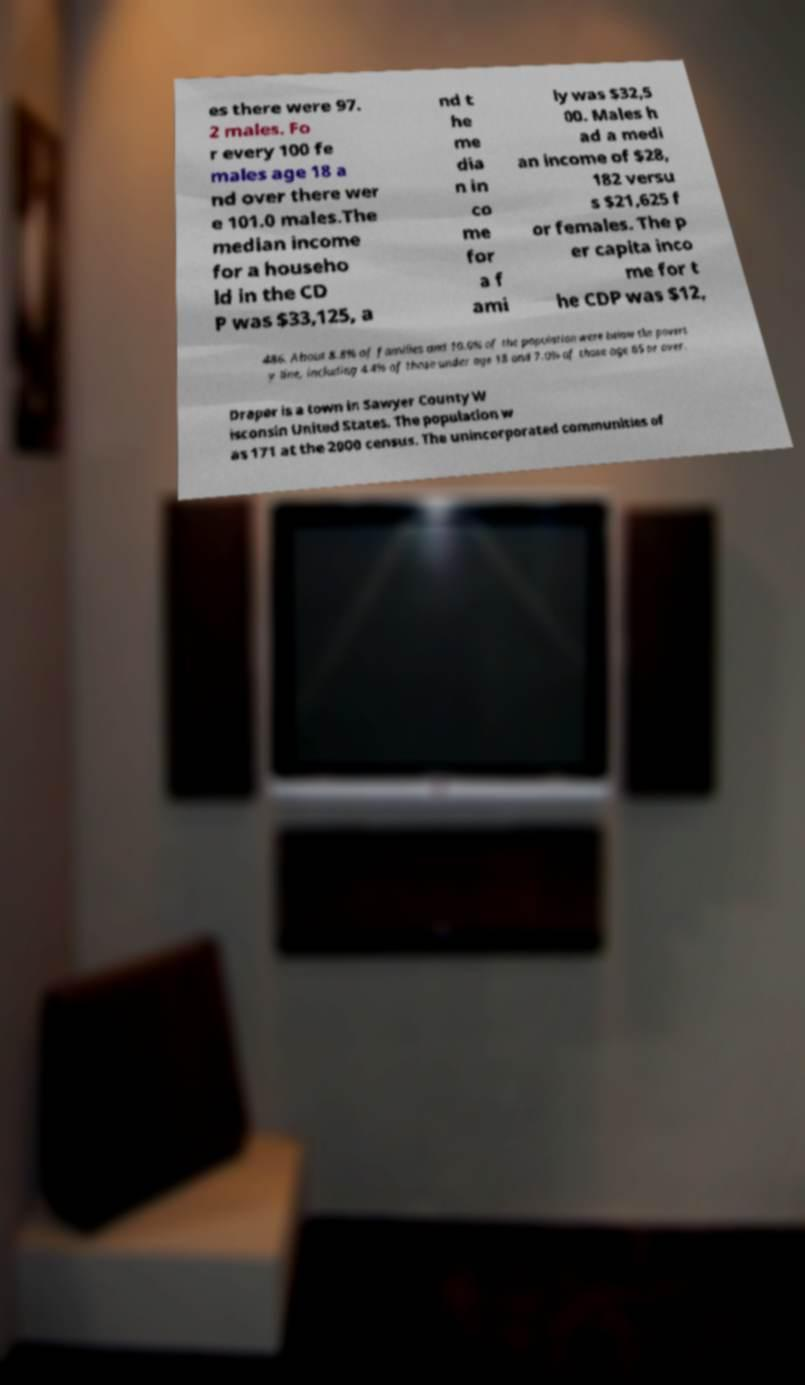There's text embedded in this image that I need extracted. Can you transcribe it verbatim? es there were 97. 2 males. Fo r every 100 fe males age 18 a nd over there wer e 101.0 males.The median income for a househo ld in the CD P was $33,125, a nd t he me dia n in co me for a f ami ly was $32,5 00. Males h ad a medi an income of $28, 182 versu s $21,625 f or females. The p er capita inco me for t he CDP was $12, 486. About 8.8% of families and 10.0% of the population were below the povert y line, including 4.4% of those under age 18 and 7.0% of those age 65 or over. Draper is a town in Sawyer County W isconsin United States. The population w as 171 at the 2000 census. The unincorporated communities of 